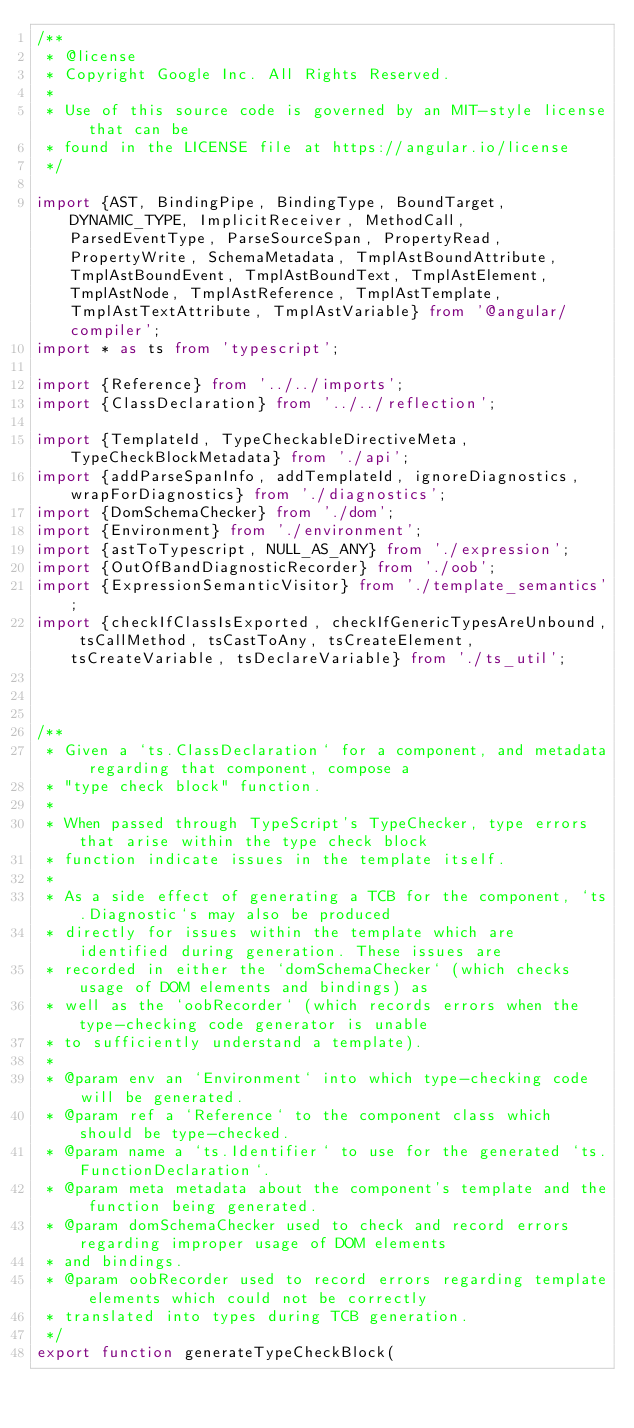<code> <loc_0><loc_0><loc_500><loc_500><_TypeScript_>/**
 * @license
 * Copyright Google Inc. All Rights Reserved.
 *
 * Use of this source code is governed by an MIT-style license that can be
 * found in the LICENSE file at https://angular.io/license
 */

import {AST, BindingPipe, BindingType, BoundTarget, DYNAMIC_TYPE, ImplicitReceiver, MethodCall, ParsedEventType, ParseSourceSpan, PropertyRead, PropertyWrite, SchemaMetadata, TmplAstBoundAttribute, TmplAstBoundEvent, TmplAstBoundText, TmplAstElement, TmplAstNode, TmplAstReference, TmplAstTemplate, TmplAstTextAttribute, TmplAstVariable} from '@angular/compiler';
import * as ts from 'typescript';

import {Reference} from '../../imports';
import {ClassDeclaration} from '../../reflection';

import {TemplateId, TypeCheckableDirectiveMeta, TypeCheckBlockMetadata} from './api';
import {addParseSpanInfo, addTemplateId, ignoreDiagnostics, wrapForDiagnostics} from './diagnostics';
import {DomSchemaChecker} from './dom';
import {Environment} from './environment';
import {astToTypescript, NULL_AS_ANY} from './expression';
import {OutOfBandDiagnosticRecorder} from './oob';
import {ExpressionSemanticVisitor} from './template_semantics';
import {checkIfClassIsExported, checkIfGenericTypesAreUnbound, tsCallMethod, tsCastToAny, tsCreateElement, tsCreateVariable, tsDeclareVariable} from './ts_util';



/**
 * Given a `ts.ClassDeclaration` for a component, and metadata regarding that component, compose a
 * "type check block" function.
 *
 * When passed through TypeScript's TypeChecker, type errors that arise within the type check block
 * function indicate issues in the template itself.
 *
 * As a side effect of generating a TCB for the component, `ts.Diagnostic`s may also be produced
 * directly for issues within the template which are identified during generation. These issues are
 * recorded in either the `domSchemaChecker` (which checks usage of DOM elements and bindings) as
 * well as the `oobRecorder` (which records errors when the type-checking code generator is unable
 * to sufficiently understand a template).
 *
 * @param env an `Environment` into which type-checking code will be generated.
 * @param ref a `Reference` to the component class which should be type-checked.
 * @param name a `ts.Identifier` to use for the generated `ts.FunctionDeclaration`.
 * @param meta metadata about the component's template and the function being generated.
 * @param domSchemaChecker used to check and record errors regarding improper usage of DOM elements
 * and bindings.
 * @param oobRecorder used to record errors regarding template elements which could not be correctly
 * translated into types during TCB generation.
 */
export function generateTypeCheckBlock(</code> 